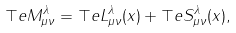Convert formula to latex. <formula><loc_0><loc_0><loc_500><loc_500>\top e { M } _ { \mu \nu } ^ { \lambda } = \top e { L } _ { \mu \nu } ^ { \lambda } ( x ) + \top e { S } _ { \mu \nu } ^ { \lambda } ( x ) ,</formula> 